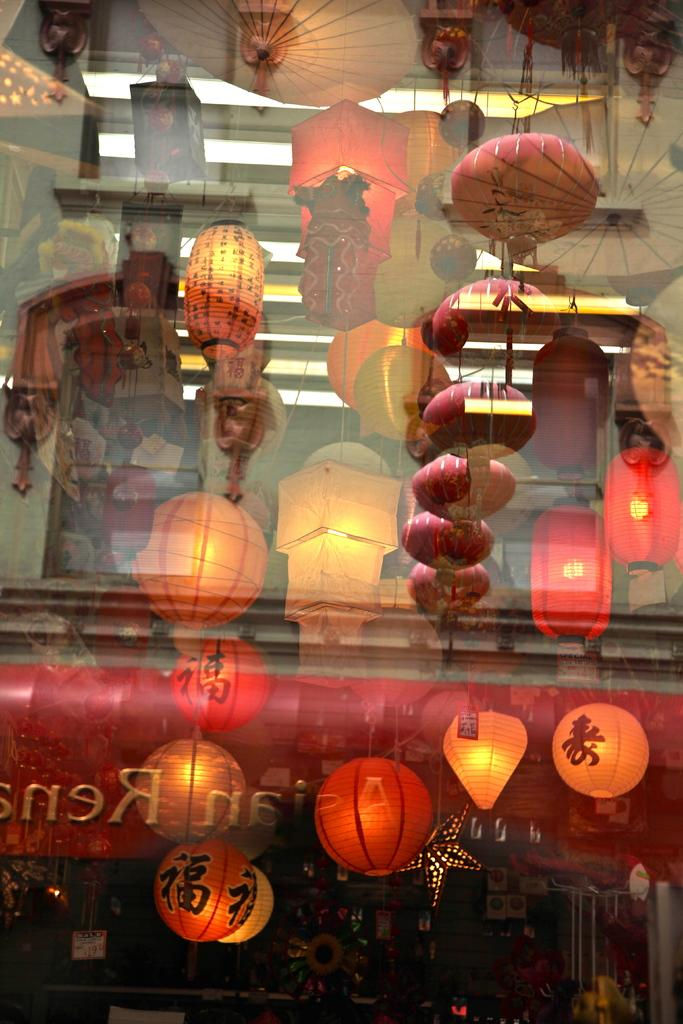What is present in the image that can hold a liquid? There is a glass in the image that can hold a liquid. What type of lighting is visible behind the glass? Decorative lamps are visible behind the glass. What other decorative items can be seen behind the glass? There are decorative objects behind the glass. What type of animal can be seen sitting on the glass in the image? There is no animal present on the glass in the image. 